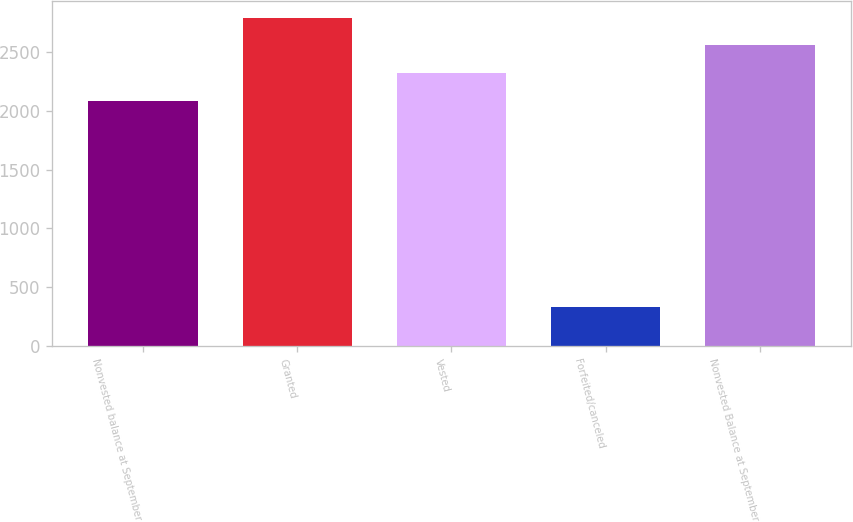Convert chart. <chart><loc_0><loc_0><loc_500><loc_500><bar_chart><fcel>Nonvested balance at September<fcel>Granted<fcel>Vested<fcel>Forfeited/canceled<fcel>Nonvested Balance at September<nl><fcel>2085<fcel>2796.3<fcel>2322.1<fcel>332<fcel>2559.2<nl></chart> 